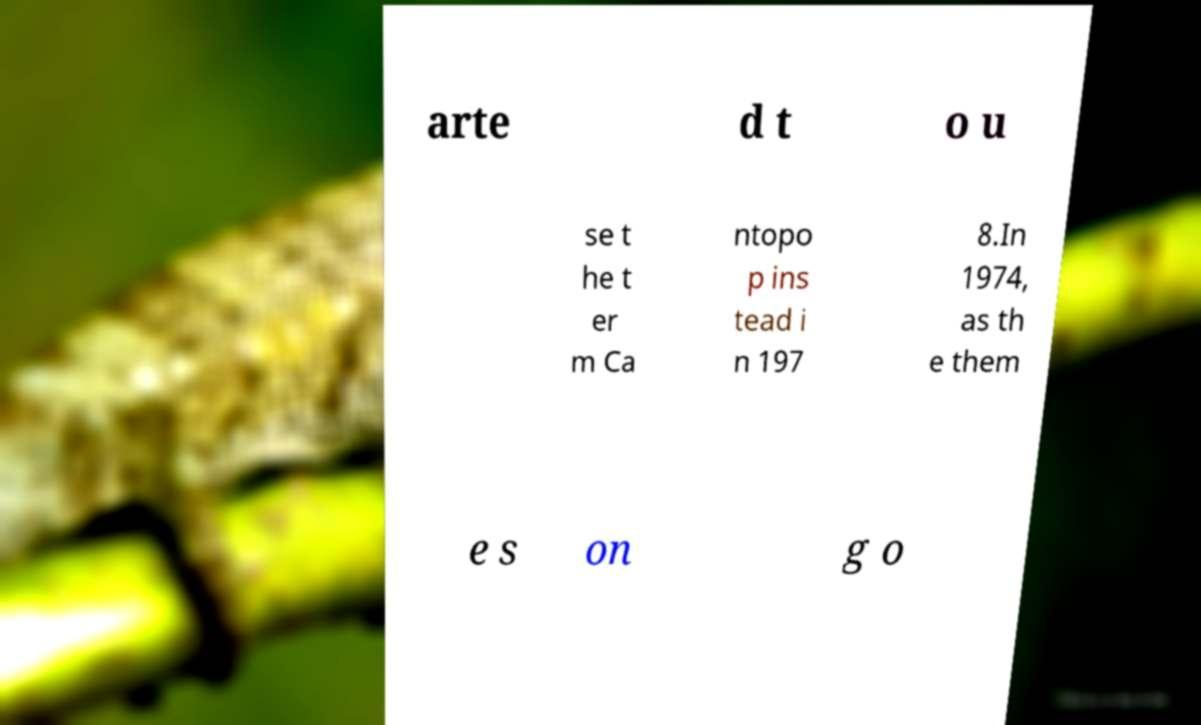Can you accurately transcribe the text from the provided image for me? arte d t o u se t he t er m Ca ntopo p ins tead i n 197 8.In 1974, as th e them e s on g o 